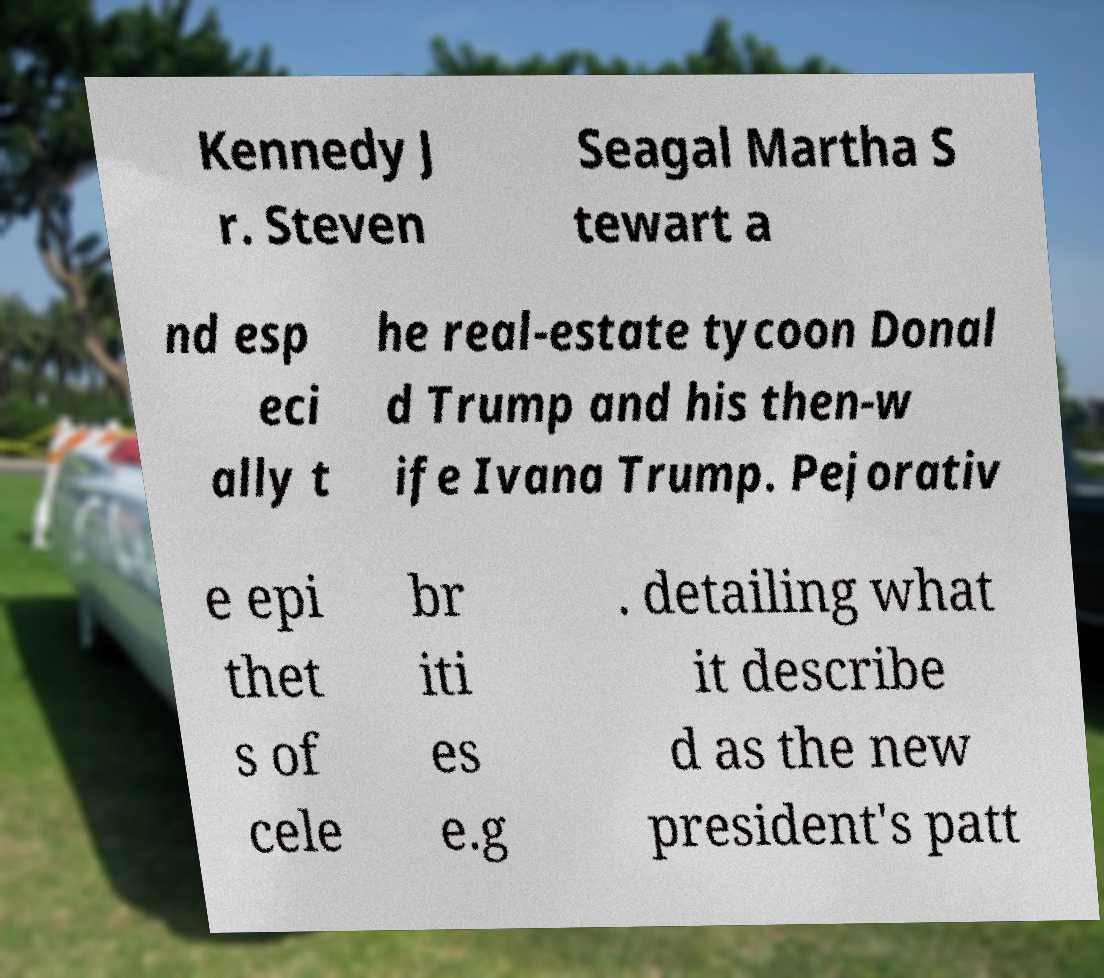Could you extract and type out the text from this image? Kennedy J r. Steven Seagal Martha S tewart a nd esp eci ally t he real-estate tycoon Donal d Trump and his then-w ife Ivana Trump. Pejorativ e epi thet s of cele br iti es e.g . detailing what it describe d as the new president's patt 